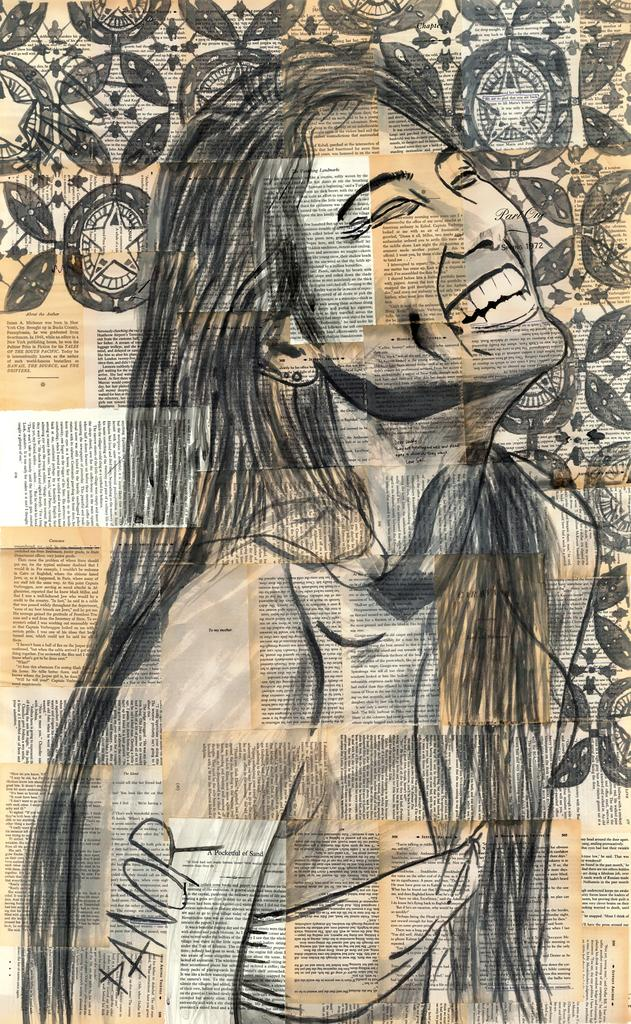<image>
Create a compact narrative representing the image presented. A drawing of a woman with PANOR on her arm. 